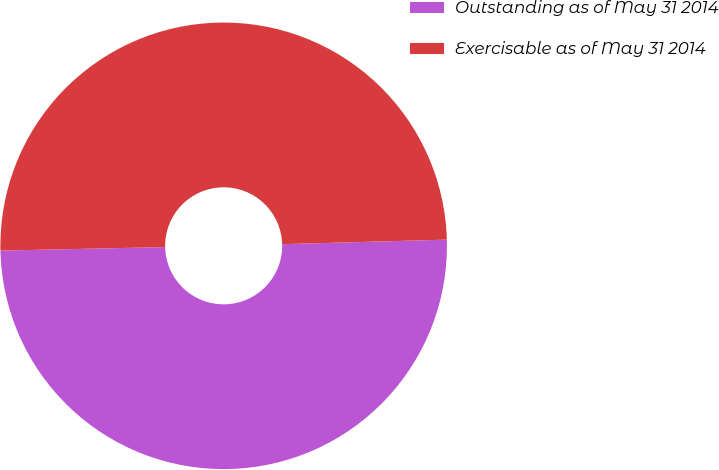Convert chart. <chart><loc_0><loc_0><loc_500><loc_500><pie_chart><fcel>Outstanding as of May 31 2014<fcel>Exercisable as of May 31 2014<nl><fcel>50.1%<fcel>49.9%<nl></chart> 